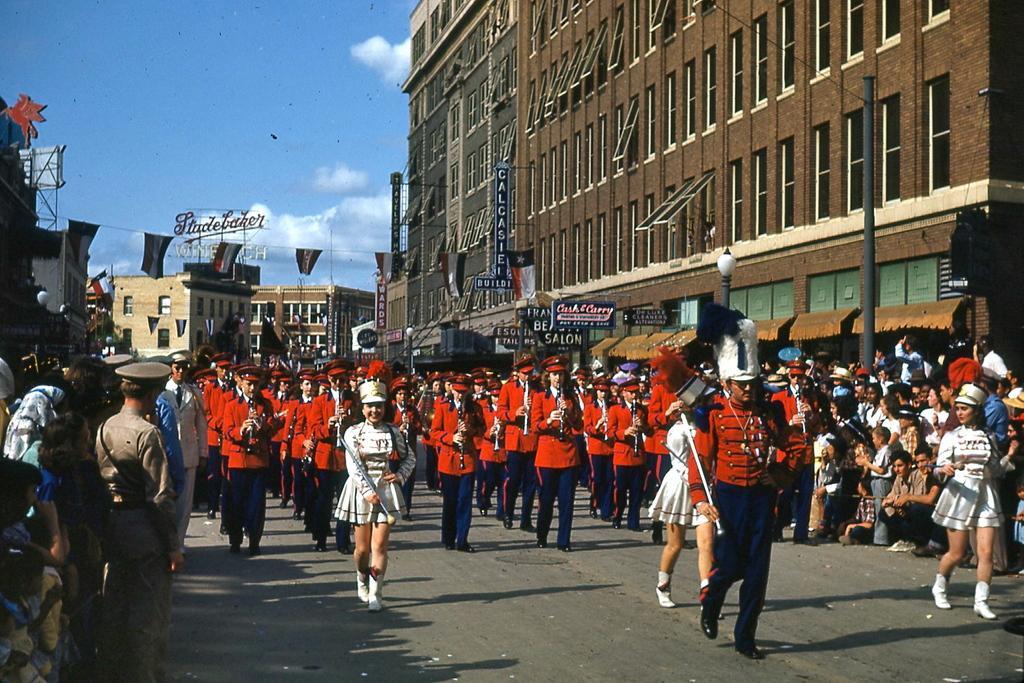In one or two sentences, can you explain what this image depicts? In the foreground of this image, there are many people standing and walking on the road. Few are holding sticks and few are playing clarinets. In the background, there are buildings, boards, flags, sky and the cloud. 